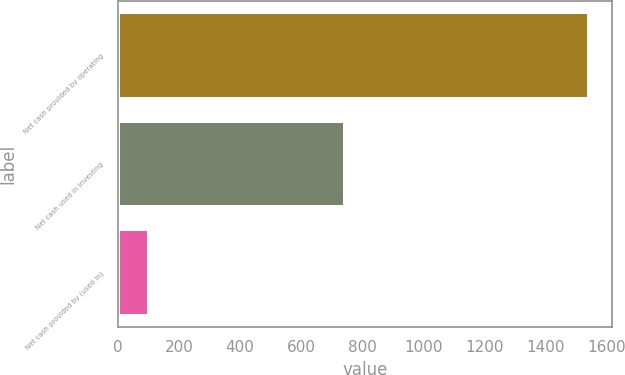<chart> <loc_0><loc_0><loc_500><loc_500><bar_chart><fcel>Net cash provided by operating<fcel>Net cash used in investing<fcel>Net cash provided by (used in)<nl><fcel>1542<fcel>743<fcel>102<nl></chart> 